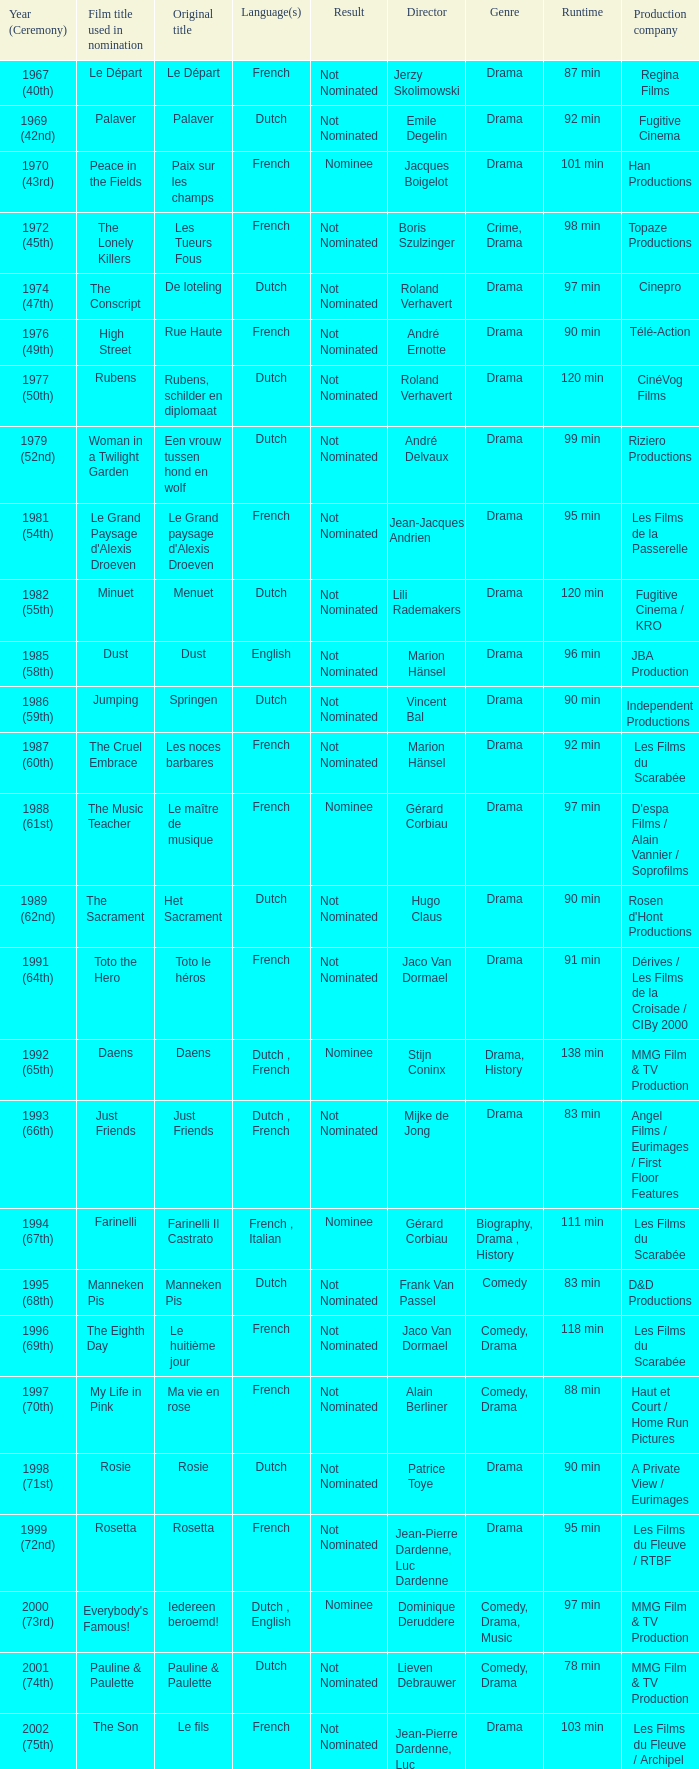What was the title used for Rosie, the film nominated for the dutch language? Rosie. 